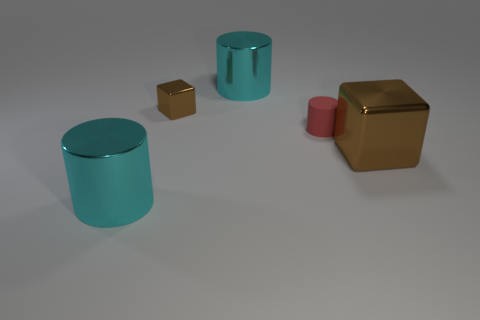What is the size of the other brown shiny object that is the same shape as the large brown shiny object?
Ensure brevity in your answer.  Small. The matte cylinder has what size?
Make the answer very short. Small. Are there more large cyan shiny objects in front of the matte thing than blue matte spheres?
Offer a very short reply. Yes. Is there anything else that is made of the same material as the tiny red cylinder?
Provide a succinct answer. No. There is a small metallic block behind the tiny red matte object; does it have the same color as the cube in front of the small metallic block?
Give a very brief answer. Yes. What material is the cyan thing to the left of the big thing behind the brown metal block in front of the small metallic cube?
Offer a terse response. Metal. Are there more big metallic cylinders than tiny rubber cubes?
Your response must be concise. Yes. Is there any other thing that has the same color as the large cube?
Your response must be concise. Yes. What is the size of the other cube that is made of the same material as the small brown cube?
Provide a succinct answer. Large. What material is the red thing?
Your answer should be compact. Rubber. 